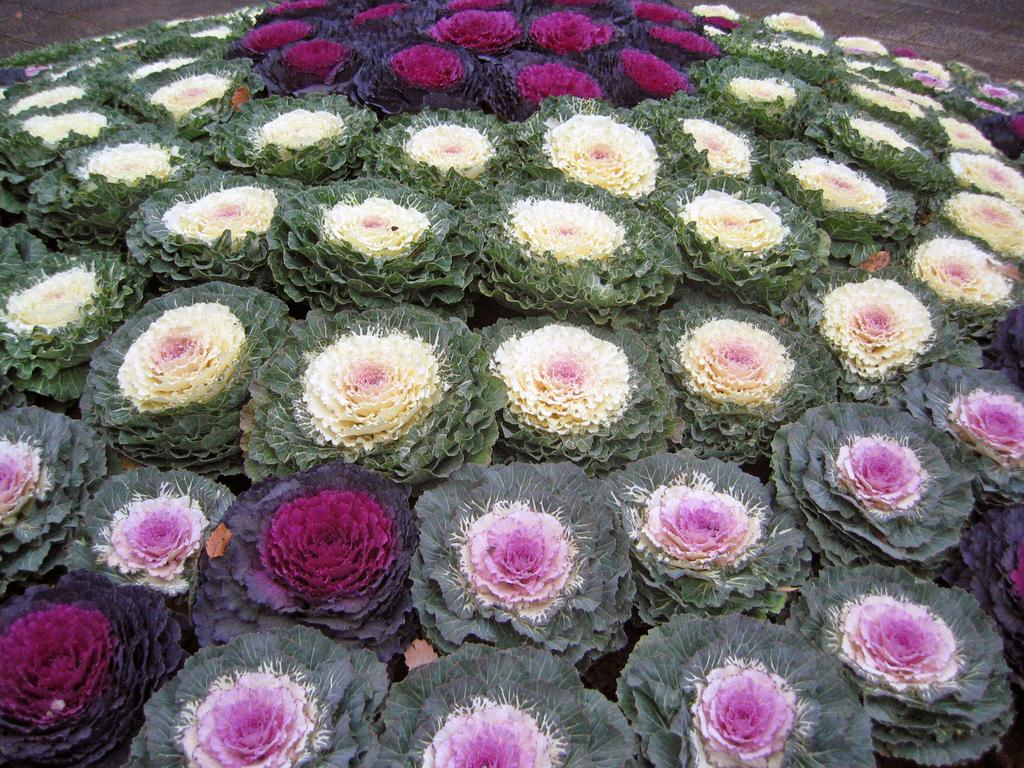What type of living organisms can be seen in the image? There are flowers in the image. Can you describe the appearance of the flowers? The flowers have different colors. What type of badge is being used to water the flowers in the image? There is no badge present in the image, and the flowers are not being watered. 